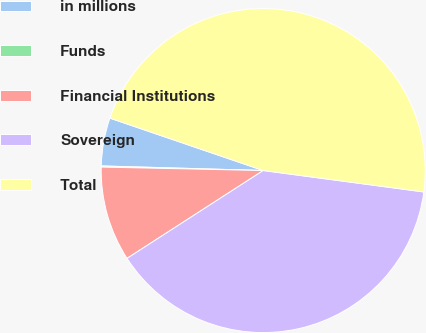Convert chart to OTSL. <chart><loc_0><loc_0><loc_500><loc_500><pie_chart><fcel>in millions<fcel>Funds<fcel>Financial Institutions<fcel>Sovereign<fcel>Total<nl><fcel>4.79%<fcel>0.11%<fcel>9.46%<fcel>38.77%<fcel>46.87%<nl></chart> 